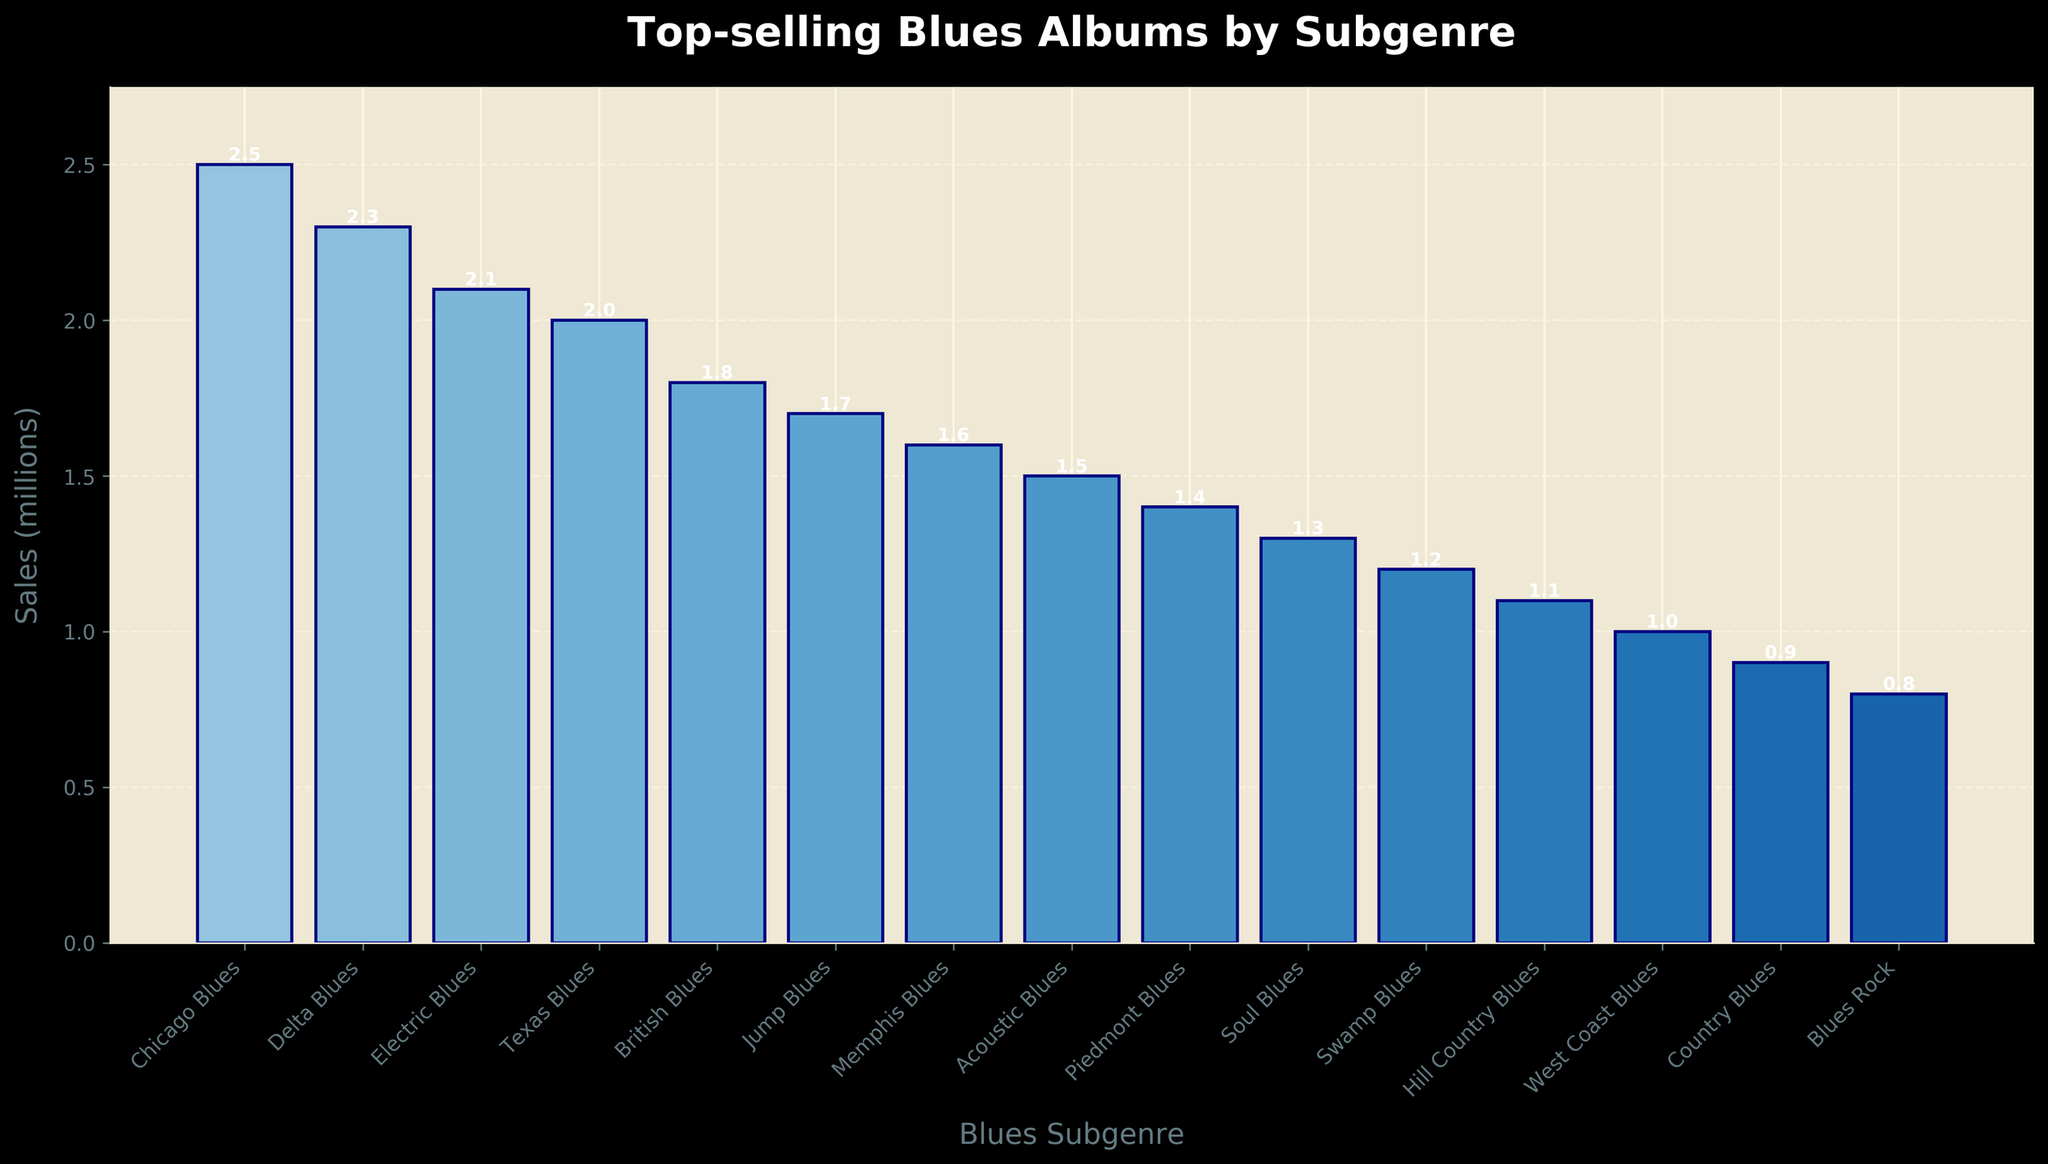Which subgenre has the highest sales figure? The bars in the chart show that "Chicago Blues" has the tallest bar, representing the highest sales figure.
Answer: Chicago Blues What is the total sales figure for the top 3 subgenres? The top 3 subgenres by sales are "Chicago Blues" (2.5 million), "Delta Blues" (2.3 million), and "Electric Blues" (2.1 million). Summing these sales: 2.5 + 2.3 + 2.1 = 6.9 million.
Answer: 6.9 million Which has more sales, "Texas Blues" or "British Blues"? By comparing the height of the bars for "Texas Blues" (2.0 million) and "British Blues" (1.8 million), "Texas Blues" has higher sales.
Answer: Texas Blues What is the sales difference between "Soul Blues" and "West Coast Blues"? The sales for "Soul Blues" are 1.3 million, and for "West Coast Blues" are 1.0 million. The difference is 1.3 - 1.0 = 0.3 million.
Answer: 0.3 million How many subgenres have a sales figure greater than 1.5 million? The bars representing sales greater than 1.5 million are Chicago Blues, Delta Blues, Electric Blues, Texas Blues, and British Blues. Counting them gives 5 subgenres.
Answer: 5 Is the sales figure for "Acoustic Blues" greater than the sales figure for "Piedmont Blues"? The bar for "Acoustic Blues" shows 1.5 million sales, and "Piedmont Blues" shows 1.4 million. Thus, "Acoustic Blues" has higher sales.
Answer: Yes What is the average sales figure for all subgenres? Sum all sales figures: 2.5 + 2.3 + 2.1 + 2.0 + 1.8 + 1.7 + 1.6 + 1.5 + 1.4 + 1.3 + 1.2 + 1.1 + 1.0 + 0.9 + 0.8 = 24.2 million. There are 15 subgenres, so the average is 24.2 / 15 ≈ 1.61 million.
Answer: 1.61 million Which subgenre has the lowest sales figure, and what is it? The bar representing "Blues Rock" is the shortest, indicating it has the lowest sales figure of 0.8 million.
Answer: Blues Rock, 0.8 million If the sales of "Memphis Blues" and "Swamp Blues" are combined, what would be the total sales? The sales for "Memphis Blues" are 1.6 million and for "Swamp Blues" are 1.2 million. Their combined sales are 1.6 + 1.2 = 2.8 million.
Answer: 2.8 million How does the sales figure for "Jump Blues" compare to the sales figure for "Country Blues"? The sales for "Jump Blues" are 1.7 million, while for "Country Blues" it is 0.9 million. "Jump Blues" has higher sales.
Answer: Jump Blues 